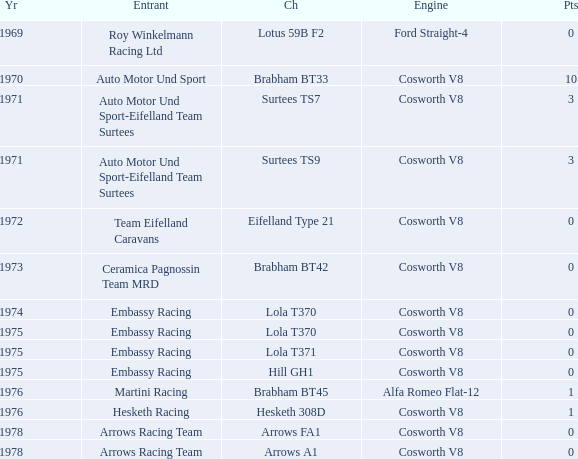In 1970, what entrant had a cosworth v8 engine? Auto Motor Und Sport. 